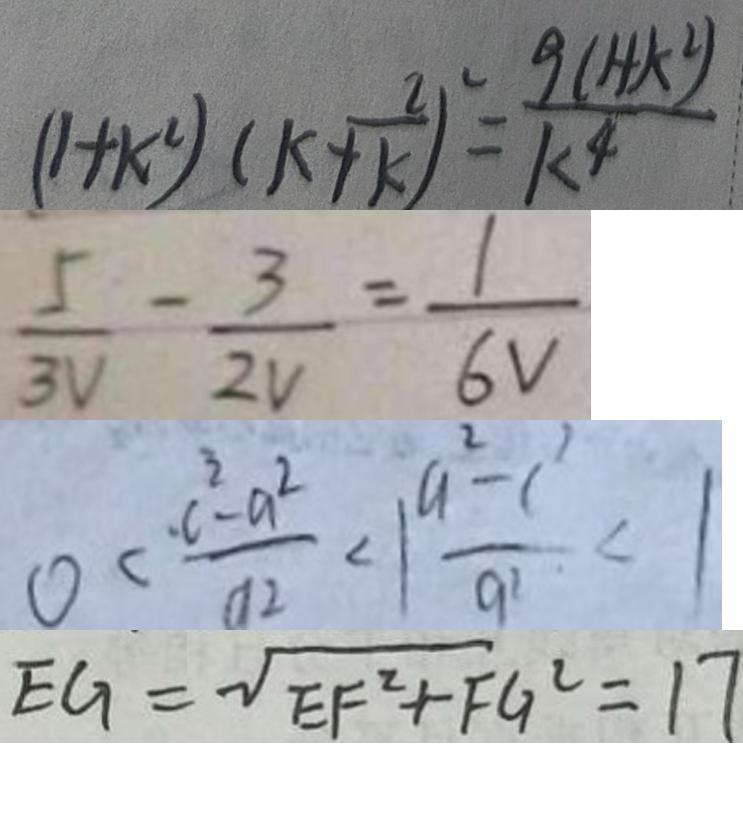<formula> <loc_0><loc_0><loc_500><loc_500>( 1 + k ^ { 2 } ) ( k + \frac { 2 } { k } ) ^ { 2 } = \frac { 9 ( 1 + k ^ { 2 } ) } { k ^ { 4 } } 
 \frac { 5 } { 3 V } - \frac { 3 } { 2 V } = \frac { 1 } { 6 V } 
 0 < \frac { \cdot c ^ { 3 } - a ^ { 2 } } { a ^ { 2 } } < 1 \frac { a ^ { 2 } - c ^ { 2 } } { q ^ { 2 } } < 1 
 E G = \sqrt { E F ^ { 2 } + F G ^ { 2 } } = 1 7</formula> 